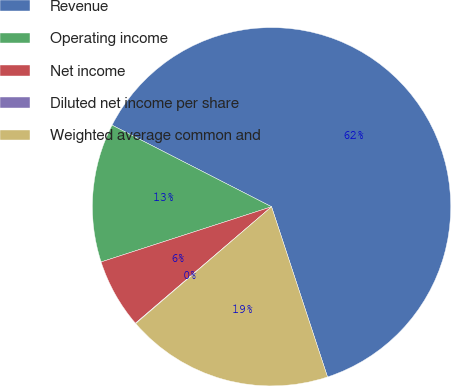<chart> <loc_0><loc_0><loc_500><loc_500><pie_chart><fcel>Revenue<fcel>Operating income<fcel>Net income<fcel>Diluted net income per share<fcel>Weighted average common and<nl><fcel>62.42%<fcel>12.51%<fcel>6.28%<fcel>0.04%<fcel>18.75%<nl></chart> 